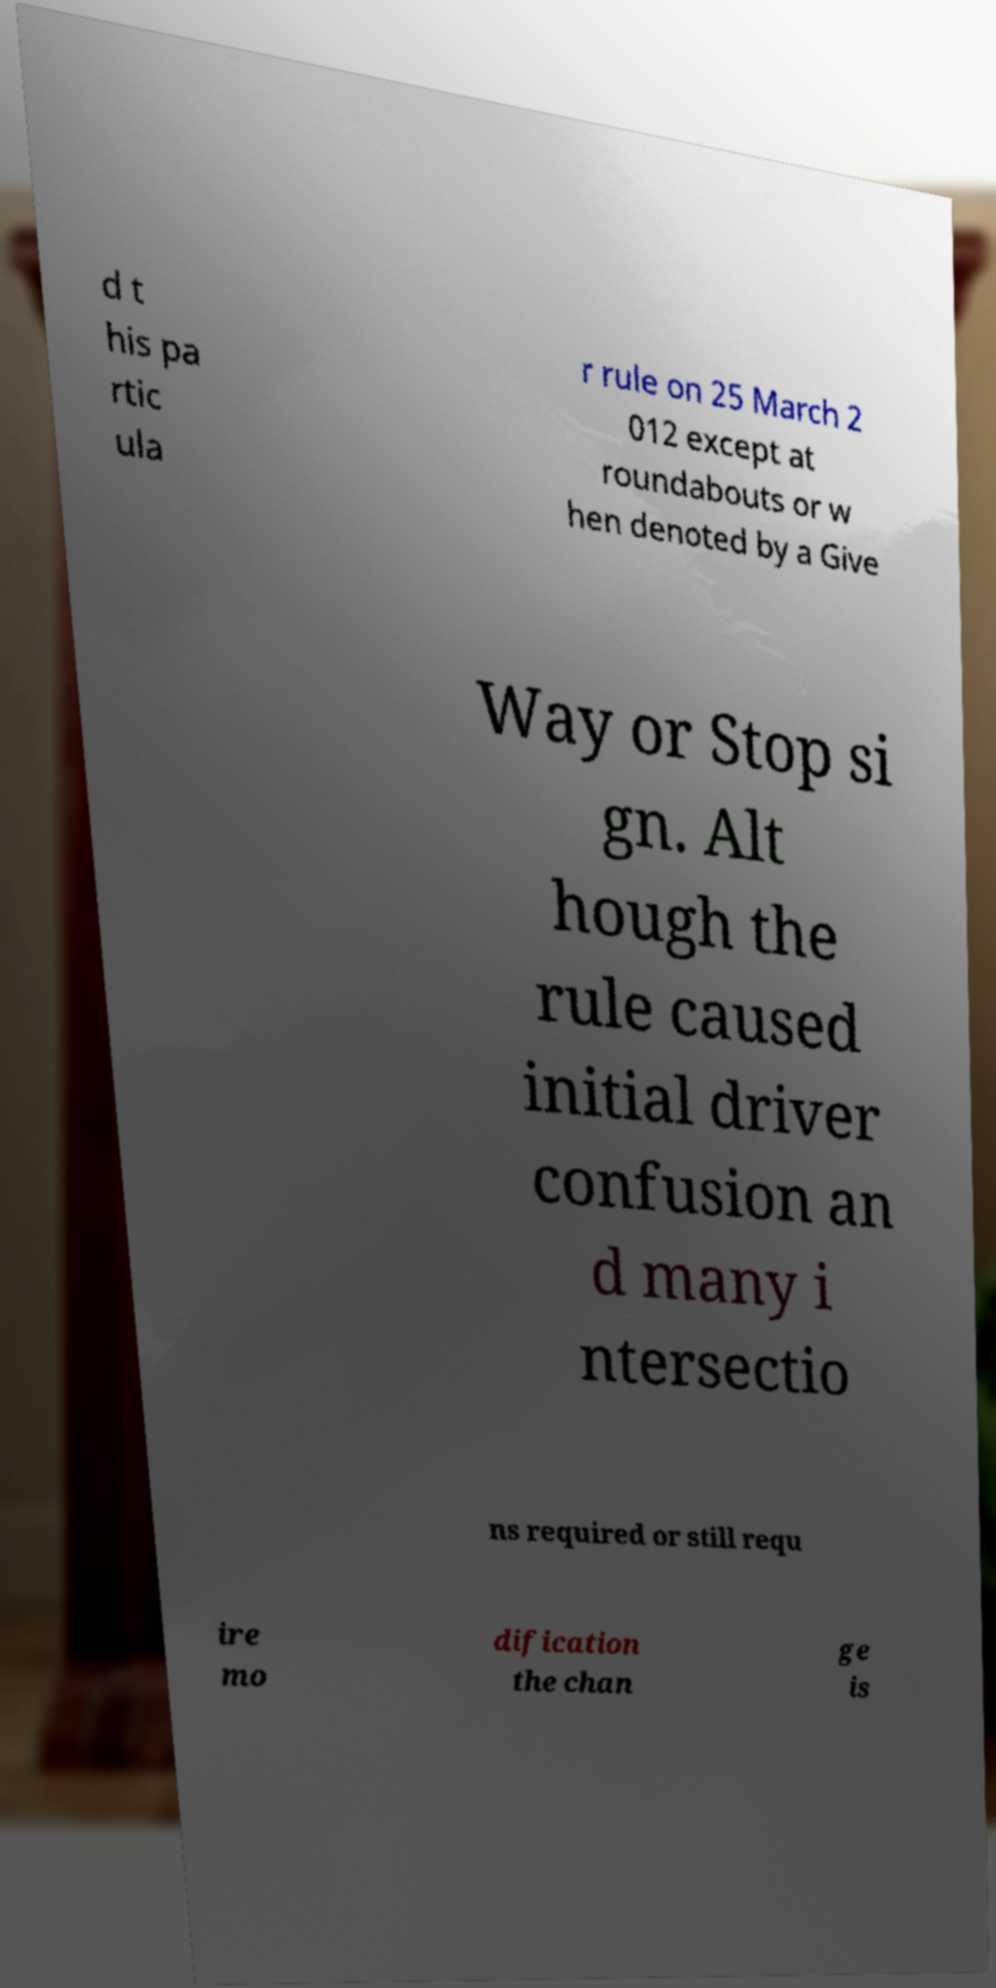Can you read and provide the text displayed in the image?This photo seems to have some interesting text. Can you extract and type it out for me? d t his pa rtic ula r rule on 25 March 2 012 except at roundabouts or w hen denoted by a Give Way or Stop si gn. Alt hough the rule caused initial driver confusion an d many i ntersectio ns required or still requ ire mo dification the chan ge is 